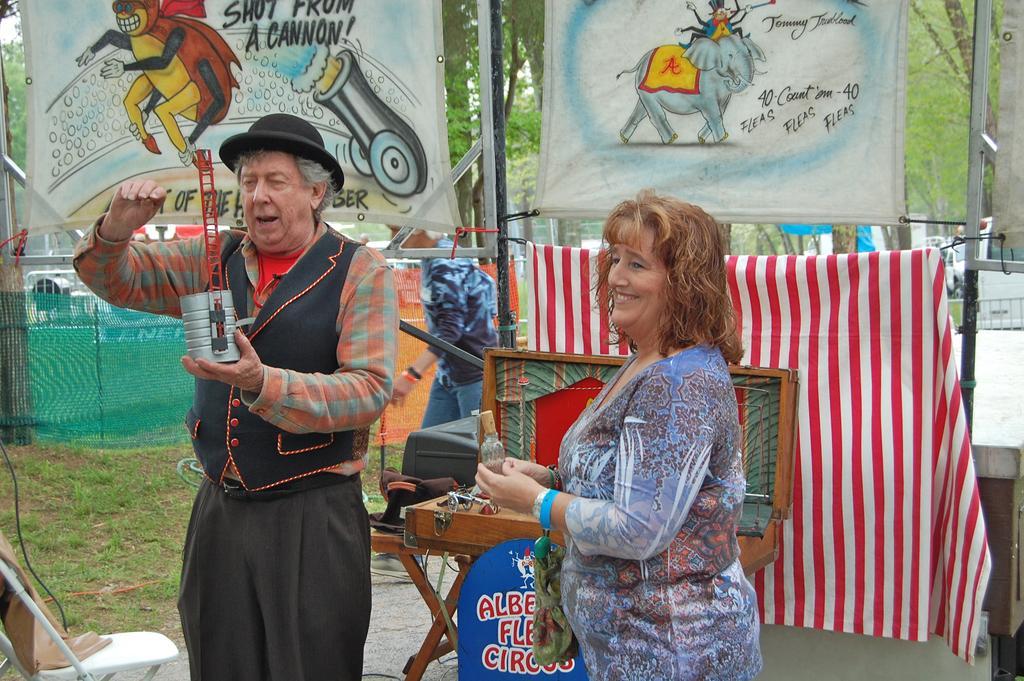Could you give a brief overview of what you see in this image? Here I can see a woman and a man are holding some objects in the hands and standing by looking at the left side. The woman is smiling and the man is speaking. Beside him there is a chair. At the back of these people there is a table and few banners. On the banners there is some text and few cartoon images. At the back of these a person is walking towards the left side. In the background there are many trees. On the left side there is a net and also I can see the grass on the ground. 